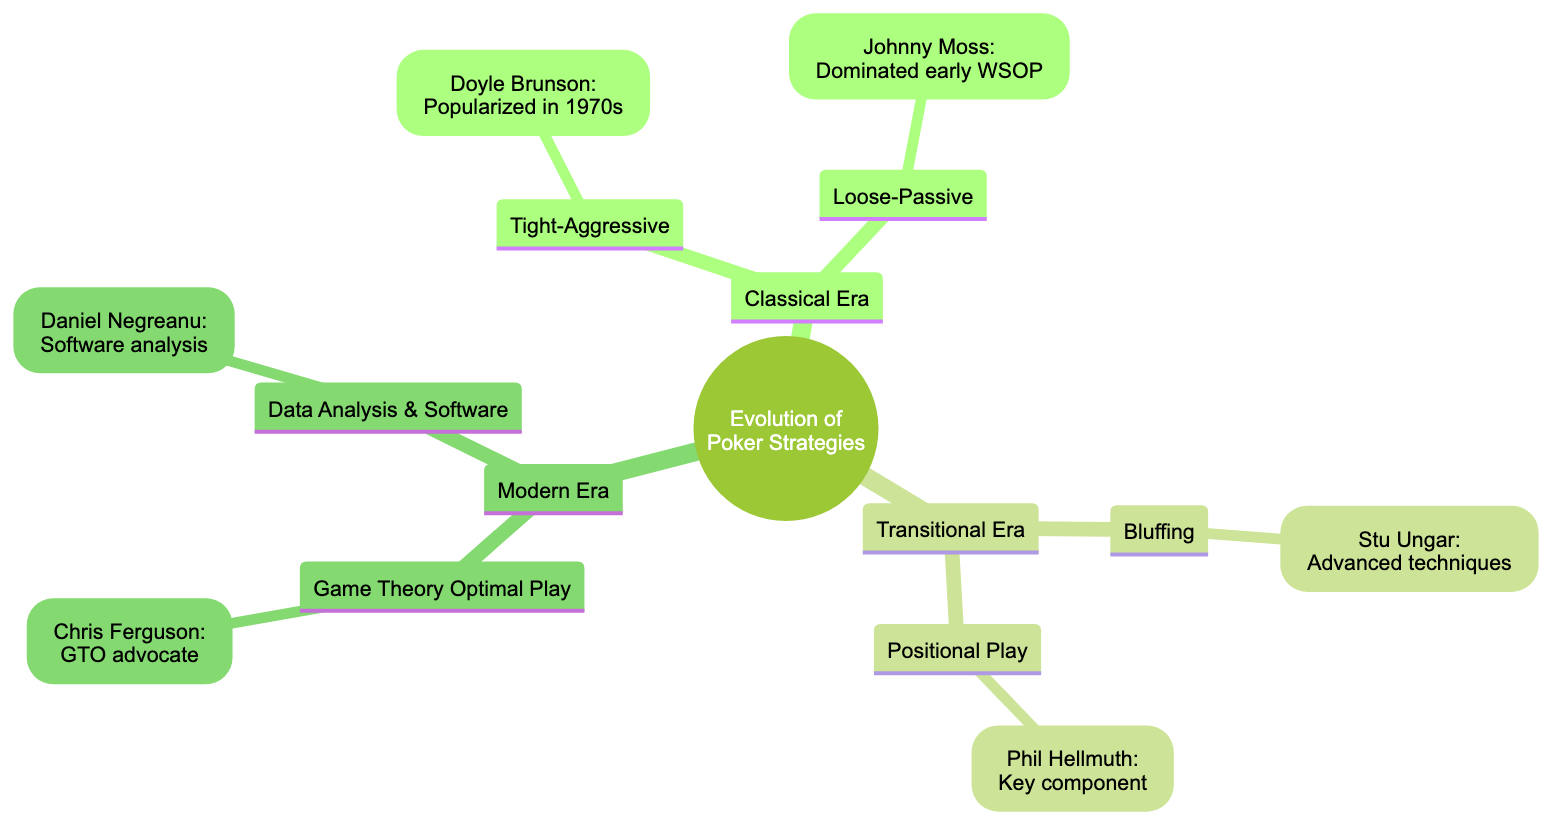What is the title of the concept map? The title is clearly labeled at the top of the diagram, indicating the main theme of the visualization.
Answer: Evolution of Poker Strategies from Classical to Modern Era How many eras are represented in the diagram? By counting the main branches of the diagram, we can see there are three distinct eras: Classical, Transitional, and Modern.
Answer: 3 Who popularized the tight-aggressive style? The diagram includes an example under Tight-Aggressive in the Classical Era, indicating Doyle Brunson's contribution to popularizing this style.
Answer: Doyle Brunson What is the strategy emphasized by Phil Hellmuth? The diagram states that Phil Hellmuth made positional play a key component of his strategy, which is directly associated with his name in the Transitional Era.
Answer: Positional Play What advanced technique is associated with Stu Ungar? According to the diagram, Stu Ungar is known for his advanced bluffing techniques, which are highlighted under the Bluffing node in the Transitional Era.
Answer: Bluffing What does "GTO" stand for in the Modern Era? The diagram does not explicitly define "GTO," but it is commonly understood to refer to Game Theory Optimal Play, which is mentioned in that section.
Answer: Game Theory Optimal Which modern poker player is mentioned for using software analysis? The Data Analysis & Software section in the Modern Era features Daniel Negreanu's contribution, indicating his use of software to refine poker strategies.
Answer: Daniel Negreanu How does the Classical Era's Loose-Passive strategy differ from Tight-Aggressive? The descriptions provided in the diagram outline that Loose-Passive involves playing many hands but rarely betting, while Tight-Aggressive focuses on playing fewer hands but betting aggressively.
Answer: Strategy differences What is a key characteristic of the Modern Era compared to earlier eras? The Modern Era integrates advanced mathematics and technology, as opposed to the more straightforward strategies of the Classical Era and the shifts toward psychological play in the Transitional Era.
Answer: Advanced mathematics and technology 